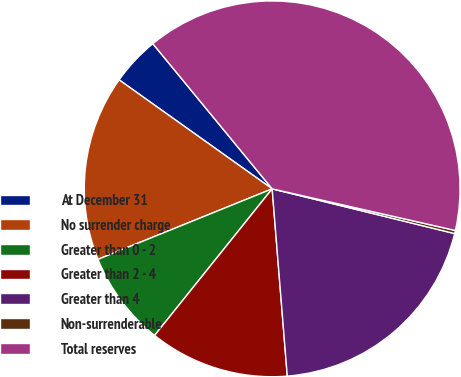Convert chart. <chart><loc_0><loc_0><loc_500><loc_500><pie_chart><fcel>At December 31<fcel>No surrender charge<fcel>Greater than 0 - 2<fcel>Greater than 2 - 4<fcel>Greater than 4<fcel>Non-surrenderable<fcel>Total reserves<nl><fcel>4.2%<fcel>15.97%<fcel>8.12%<fcel>12.04%<fcel>19.89%<fcel>0.27%<fcel>39.51%<nl></chart> 